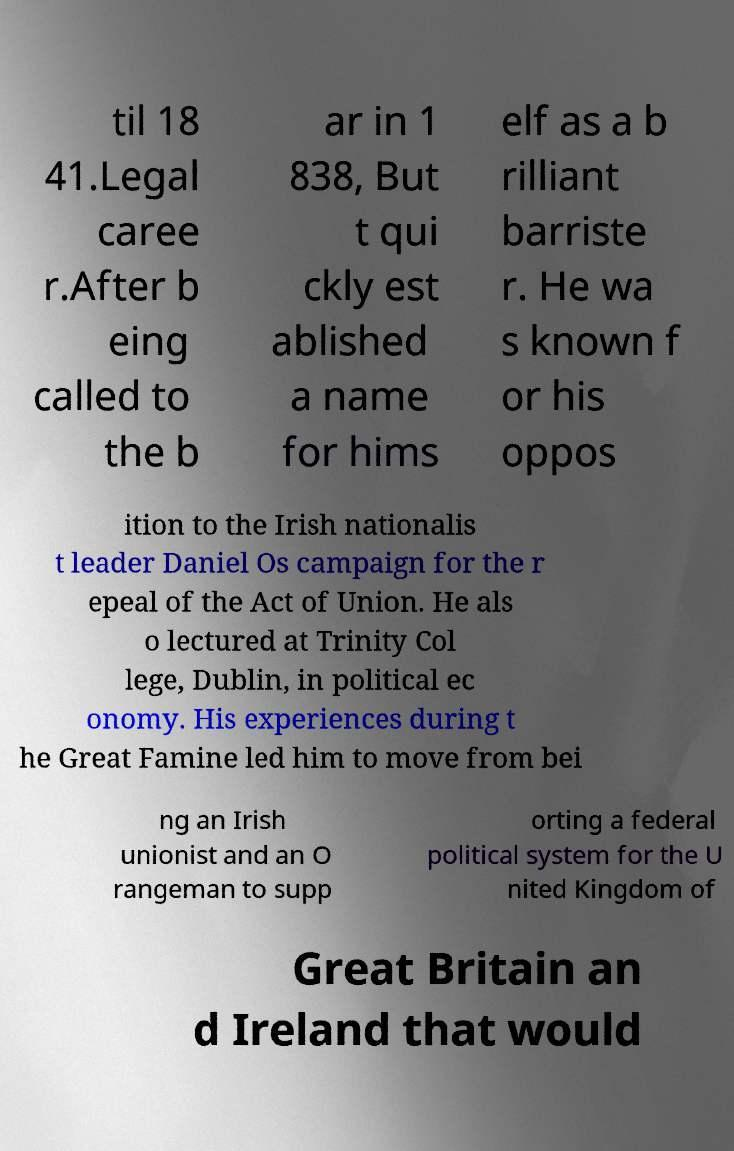There's text embedded in this image that I need extracted. Can you transcribe it verbatim? til 18 41.Legal caree r.After b eing called to the b ar in 1 838, But t qui ckly est ablished a name for hims elf as a b rilliant barriste r. He wa s known f or his oppos ition to the Irish nationalis t leader Daniel Os campaign for the r epeal of the Act of Union. He als o lectured at Trinity Col lege, Dublin, in political ec onomy. His experiences during t he Great Famine led him to move from bei ng an Irish unionist and an O rangeman to supp orting a federal political system for the U nited Kingdom of Great Britain an d Ireland that would 